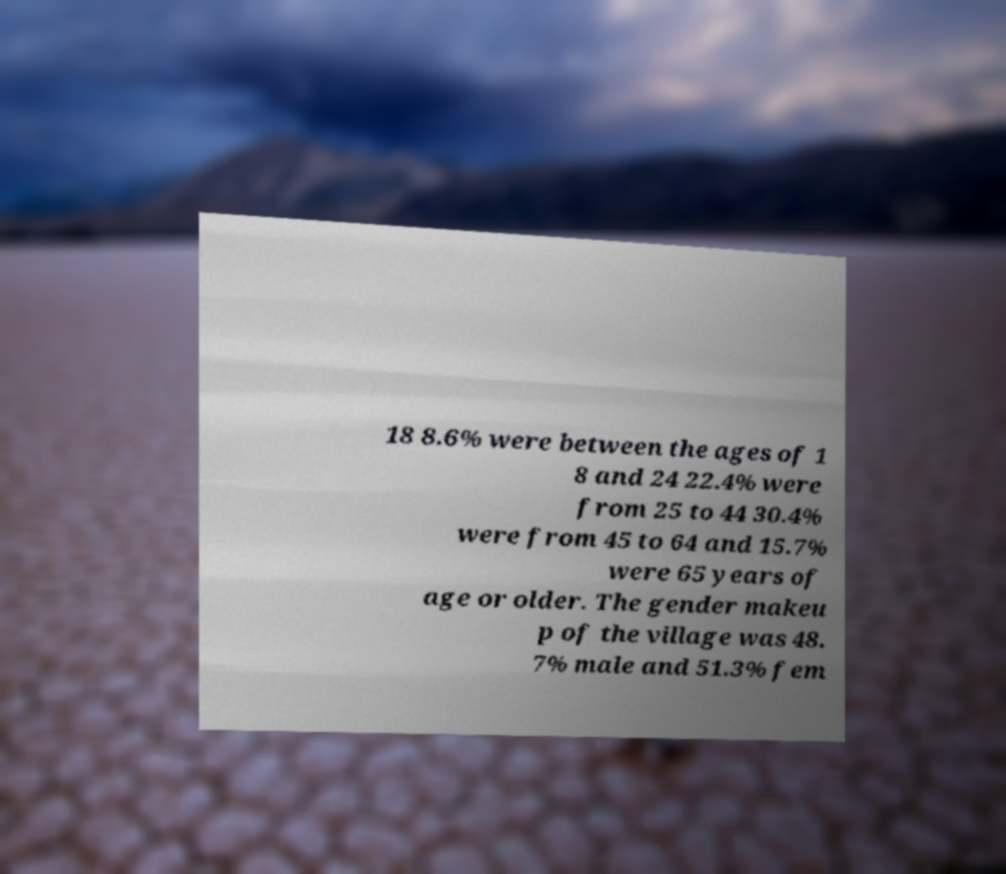Please identify and transcribe the text found in this image. 18 8.6% were between the ages of 1 8 and 24 22.4% were from 25 to 44 30.4% were from 45 to 64 and 15.7% were 65 years of age or older. The gender makeu p of the village was 48. 7% male and 51.3% fem 